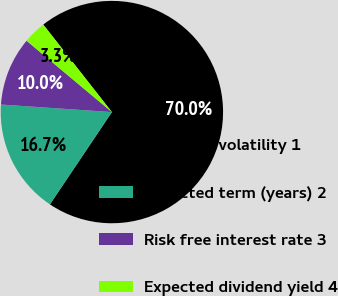Convert chart. <chart><loc_0><loc_0><loc_500><loc_500><pie_chart><fcel>Expected volatility 1<fcel>Expected term (years) 2<fcel>Risk free interest rate 3<fcel>Expected dividend yield 4<nl><fcel>70.0%<fcel>16.67%<fcel>10.0%<fcel>3.33%<nl></chart> 